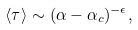<formula> <loc_0><loc_0><loc_500><loc_500>\langle \tau \rangle \sim ( \alpha - \alpha _ { c } ) ^ { - \epsilon } ,</formula> 